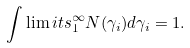Convert formula to latex. <formula><loc_0><loc_0><loc_500><loc_500>\int \lim i t s _ { 1 } ^ { \infty } N ( \gamma _ { i } ) d \gamma _ { i } = 1 .</formula> 